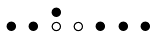Convert formula to latex. <formula><loc_0><loc_0><loc_500><loc_500>\begin{smallmatrix} & & \bullet \\ \bullet & \bullet & \circ & \circ & \bullet & \bullet & \bullet & \\ \end{smallmatrix}</formula> 